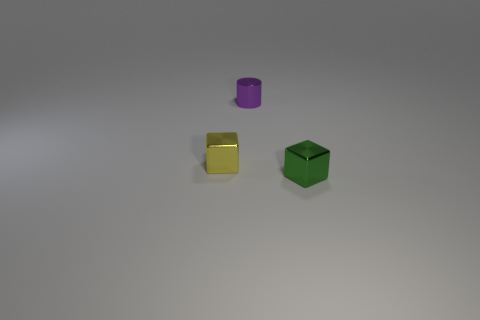Add 3 tiny metal cubes. How many objects exist? 6 Subtract all cylinders. How many objects are left? 2 Add 2 small metallic objects. How many small metallic objects exist? 5 Subtract 0 brown balls. How many objects are left? 3 Subtract all small yellow things. Subtract all tiny green blocks. How many objects are left? 1 Add 1 blocks. How many blocks are left? 3 